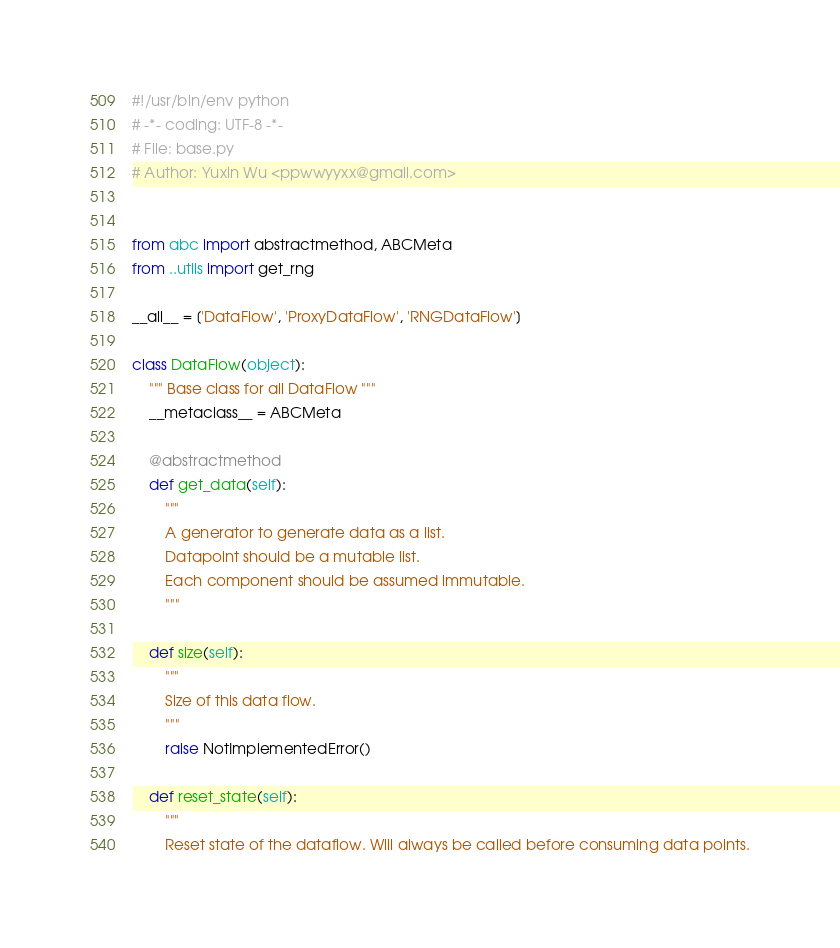Convert code to text. <code><loc_0><loc_0><loc_500><loc_500><_Python_>#!/usr/bin/env python
# -*- coding: UTF-8 -*-
# File: base.py
# Author: Yuxin Wu <ppwwyyxx@gmail.com>


from abc import abstractmethod, ABCMeta
from ..utils import get_rng

__all__ = ['DataFlow', 'ProxyDataFlow', 'RNGDataFlow']

class DataFlow(object):
    """ Base class for all DataFlow """
    __metaclass__ = ABCMeta

    @abstractmethod
    def get_data(self):
        """
        A generator to generate data as a list.
        Datapoint should be a mutable list.
        Each component should be assumed immutable.
        """

    def size(self):
        """
        Size of this data flow.
        """
        raise NotImplementedError()

    def reset_state(self):
        """
        Reset state of the dataflow. Will always be called before consuming data points.</code> 